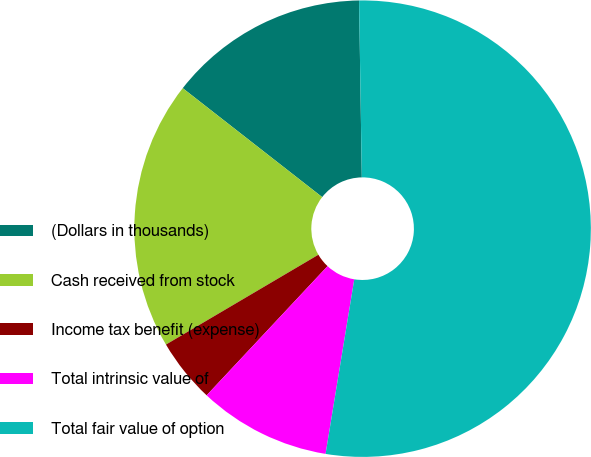Convert chart to OTSL. <chart><loc_0><loc_0><loc_500><loc_500><pie_chart><fcel>(Dollars in thousands)<fcel>Cash received from stock<fcel>Income tax benefit (expense)<fcel>Total intrinsic value of<fcel>Total fair value of option<nl><fcel>14.2%<fcel>19.03%<fcel>4.55%<fcel>9.38%<fcel>52.84%<nl></chart> 